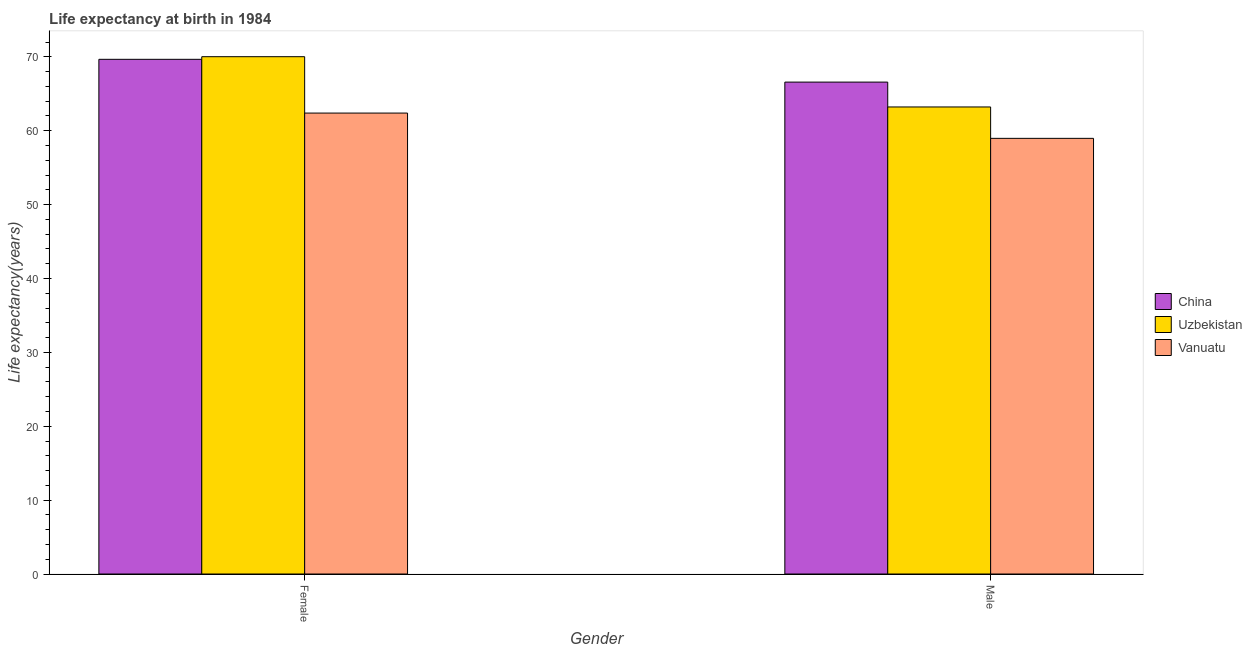How many bars are there on the 1st tick from the right?
Your response must be concise. 3. What is the label of the 2nd group of bars from the left?
Make the answer very short. Male. What is the life expectancy(male) in China?
Your answer should be compact. 66.59. Across all countries, what is the maximum life expectancy(female)?
Your answer should be very brief. 70.03. Across all countries, what is the minimum life expectancy(male)?
Give a very brief answer. 58.97. In which country was the life expectancy(male) maximum?
Provide a succinct answer. China. In which country was the life expectancy(male) minimum?
Ensure brevity in your answer.  Vanuatu. What is the total life expectancy(female) in the graph?
Offer a very short reply. 202.09. What is the difference between the life expectancy(female) in China and that in Uzbekistan?
Your answer should be very brief. -0.36. What is the difference between the life expectancy(male) in Uzbekistan and the life expectancy(female) in Vanuatu?
Provide a succinct answer. 0.83. What is the average life expectancy(female) per country?
Offer a very short reply. 67.36. What is the difference between the life expectancy(male) and life expectancy(female) in China?
Ensure brevity in your answer.  -3.08. In how many countries, is the life expectancy(female) greater than 60 years?
Make the answer very short. 3. What is the ratio of the life expectancy(male) in Uzbekistan to that in Vanuatu?
Make the answer very short. 1.07. What does the 2nd bar from the left in Female represents?
Make the answer very short. Uzbekistan. What does the 1st bar from the right in Male represents?
Provide a short and direct response. Vanuatu. Are all the bars in the graph horizontal?
Keep it short and to the point. No. Does the graph contain any zero values?
Your response must be concise. No. Does the graph contain grids?
Provide a succinct answer. No. What is the title of the graph?
Ensure brevity in your answer.  Life expectancy at birth in 1984. What is the label or title of the Y-axis?
Your answer should be very brief. Life expectancy(years). What is the Life expectancy(years) in China in Female?
Your answer should be very brief. 69.67. What is the Life expectancy(years) of Uzbekistan in Female?
Offer a terse response. 70.03. What is the Life expectancy(years) in Vanuatu in Female?
Your answer should be very brief. 62.4. What is the Life expectancy(years) of China in Male?
Offer a terse response. 66.59. What is the Life expectancy(years) of Uzbekistan in Male?
Ensure brevity in your answer.  63.22. What is the Life expectancy(years) in Vanuatu in Male?
Your answer should be very brief. 58.97. Across all Gender, what is the maximum Life expectancy(years) of China?
Keep it short and to the point. 69.67. Across all Gender, what is the maximum Life expectancy(years) of Uzbekistan?
Keep it short and to the point. 70.03. Across all Gender, what is the maximum Life expectancy(years) in Vanuatu?
Make the answer very short. 62.4. Across all Gender, what is the minimum Life expectancy(years) of China?
Offer a very short reply. 66.59. Across all Gender, what is the minimum Life expectancy(years) in Uzbekistan?
Give a very brief answer. 63.22. Across all Gender, what is the minimum Life expectancy(years) in Vanuatu?
Offer a terse response. 58.97. What is the total Life expectancy(years) of China in the graph?
Offer a very short reply. 136.26. What is the total Life expectancy(years) of Uzbekistan in the graph?
Provide a short and direct response. 133.25. What is the total Life expectancy(years) of Vanuatu in the graph?
Provide a short and direct response. 121.37. What is the difference between the Life expectancy(years) in China in Female and that in Male?
Keep it short and to the point. 3.08. What is the difference between the Life expectancy(years) of Uzbekistan in Female and that in Male?
Provide a succinct answer. 6.81. What is the difference between the Life expectancy(years) in Vanuatu in Female and that in Male?
Make the answer very short. 3.42. What is the difference between the Life expectancy(years) in China in Female and the Life expectancy(years) in Uzbekistan in Male?
Provide a succinct answer. 6.45. What is the difference between the Life expectancy(years) in China in Female and the Life expectancy(years) in Vanuatu in Male?
Your answer should be very brief. 10.7. What is the difference between the Life expectancy(years) of Uzbekistan in Female and the Life expectancy(years) of Vanuatu in Male?
Keep it short and to the point. 11.05. What is the average Life expectancy(years) of China per Gender?
Provide a short and direct response. 68.13. What is the average Life expectancy(years) in Uzbekistan per Gender?
Your answer should be very brief. 66.62. What is the average Life expectancy(years) of Vanuatu per Gender?
Ensure brevity in your answer.  60.68. What is the difference between the Life expectancy(years) in China and Life expectancy(years) in Uzbekistan in Female?
Provide a short and direct response. -0.36. What is the difference between the Life expectancy(years) in China and Life expectancy(years) in Vanuatu in Female?
Your response must be concise. 7.28. What is the difference between the Life expectancy(years) in Uzbekistan and Life expectancy(years) in Vanuatu in Female?
Offer a terse response. 7.63. What is the difference between the Life expectancy(years) in China and Life expectancy(years) in Uzbekistan in Male?
Provide a short and direct response. 3.37. What is the difference between the Life expectancy(years) in China and Life expectancy(years) in Vanuatu in Male?
Provide a succinct answer. 7.62. What is the difference between the Life expectancy(years) in Uzbekistan and Life expectancy(years) in Vanuatu in Male?
Ensure brevity in your answer.  4.25. What is the ratio of the Life expectancy(years) in China in Female to that in Male?
Your response must be concise. 1.05. What is the ratio of the Life expectancy(years) of Uzbekistan in Female to that in Male?
Your answer should be compact. 1.11. What is the ratio of the Life expectancy(years) of Vanuatu in Female to that in Male?
Your response must be concise. 1.06. What is the difference between the highest and the second highest Life expectancy(years) in China?
Offer a very short reply. 3.08. What is the difference between the highest and the second highest Life expectancy(years) in Uzbekistan?
Ensure brevity in your answer.  6.81. What is the difference between the highest and the second highest Life expectancy(years) of Vanuatu?
Keep it short and to the point. 3.42. What is the difference between the highest and the lowest Life expectancy(years) of China?
Your answer should be compact. 3.08. What is the difference between the highest and the lowest Life expectancy(years) of Uzbekistan?
Ensure brevity in your answer.  6.81. What is the difference between the highest and the lowest Life expectancy(years) in Vanuatu?
Make the answer very short. 3.42. 